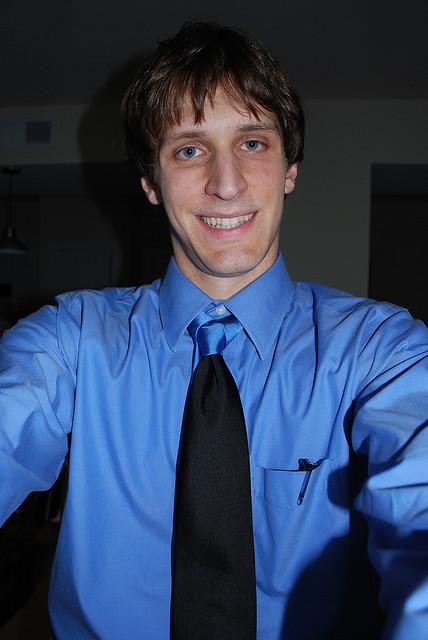What color is the man's shirt?
Answer briefly. Blue. What does the man have in his pocket?
Give a very brief answer. Pen. Is the man bearded?
Be succinct. No. What is the man using to communicate?
Give a very brief answer. Camera. Is the man smiling?
Quick response, please. Yes. Is the man happy?
Keep it brief. Yes. Is this man smiling?
Quick response, please. Yes. Who has her mouth open?
Give a very brief answer. No 1. Is the man's tie the same color as his shirt?
Concise answer only. No. What kind of tie does the man have on?
Quick response, please. Black. 